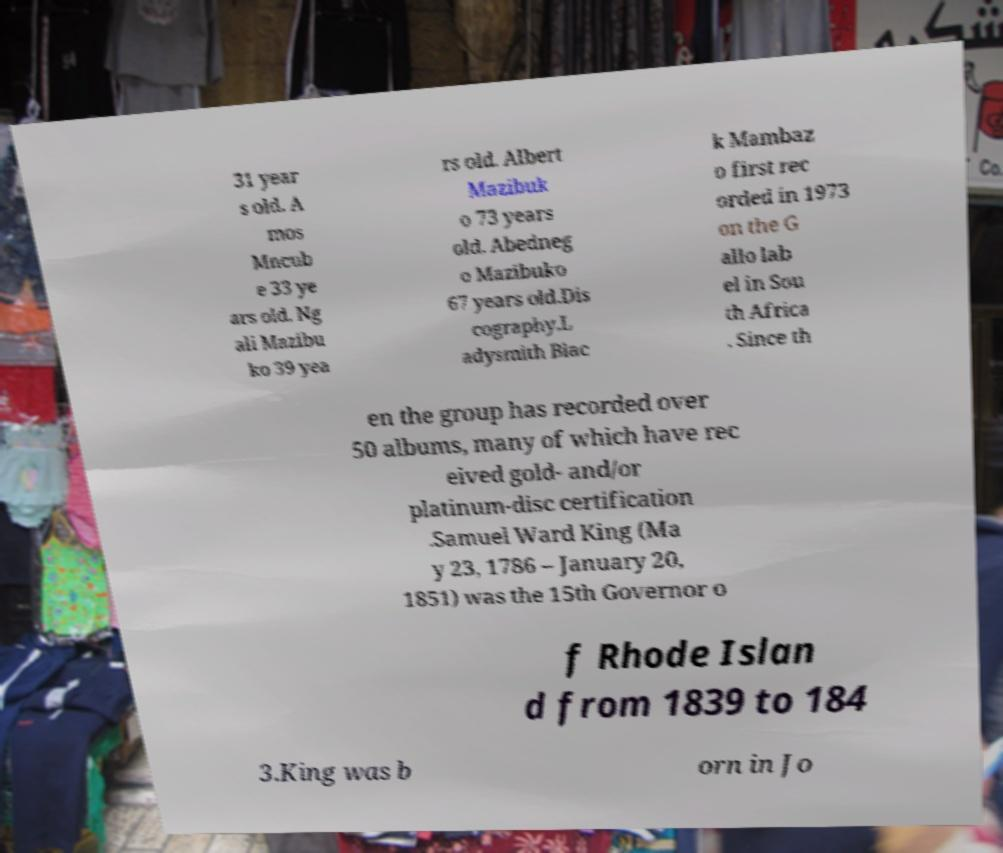Can you read and provide the text displayed in the image?This photo seems to have some interesting text. Can you extract and type it out for me? 31 year s old. A mos Mncub e 33 ye ars old. Ng ali Mazibu ko 39 yea rs old. Albert Mazibuk o 73 years old. Abedneg o Mazibuko 67 years old.Dis cography.L adysmith Blac k Mambaz o first rec orded in 1973 on the G allo lab el in Sou th Africa . Since th en the group has recorded over 50 albums, many of which have rec eived gold- and/or platinum-disc certification .Samuel Ward King (Ma y 23, 1786 – January 20, 1851) was the 15th Governor o f Rhode Islan d from 1839 to 184 3.King was b orn in Jo 